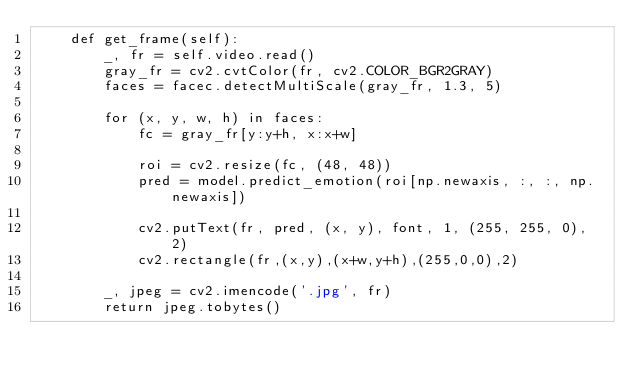Convert code to text. <code><loc_0><loc_0><loc_500><loc_500><_Python_>    def get_frame(self):
        _, fr = self.video.read()
        gray_fr = cv2.cvtColor(fr, cv2.COLOR_BGR2GRAY)
        faces = facec.detectMultiScale(gray_fr, 1.3, 5)

        for (x, y, w, h) in faces:
            fc = gray_fr[y:y+h, x:x+w]

            roi = cv2.resize(fc, (48, 48))
            pred = model.predict_emotion(roi[np.newaxis, :, :, np.newaxis])

            cv2.putText(fr, pred, (x, y), font, 1, (255, 255, 0), 2)
            cv2.rectangle(fr,(x,y),(x+w,y+h),(255,0,0),2)

        _, jpeg = cv2.imencode('.jpg', fr)
        return jpeg.tobytes()
</code> 